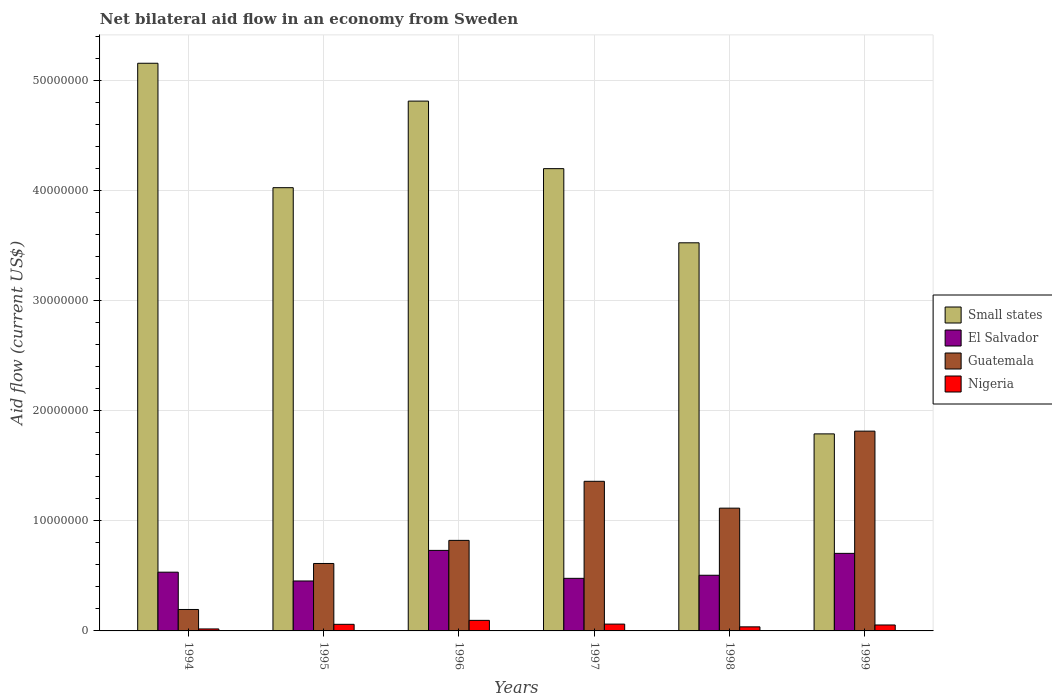Are the number of bars per tick equal to the number of legend labels?
Offer a very short reply. Yes. How many bars are there on the 3rd tick from the right?
Keep it short and to the point. 4. In how many cases, is the number of bars for a given year not equal to the number of legend labels?
Your answer should be very brief. 0. What is the net bilateral aid flow in El Salvador in 1998?
Your answer should be compact. 5.06e+06. Across all years, what is the maximum net bilateral aid flow in Nigeria?
Provide a succinct answer. 9.60e+05. Across all years, what is the minimum net bilateral aid flow in Guatemala?
Offer a very short reply. 1.95e+06. In which year was the net bilateral aid flow in Small states maximum?
Provide a short and direct response. 1994. In which year was the net bilateral aid flow in Small states minimum?
Your answer should be very brief. 1999. What is the total net bilateral aid flow in El Salvador in the graph?
Your answer should be compact. 3.41e+07. What is the difference between the net bilateral aid flow in El Salvador in 1994 and that in 1999?
Provide a succinct answer. -1.71e+06. What is the difference between the net bilateral aid flow in Nigeria in 1997 and the net bilateral aid flow in El Salvador in 1994?
Your answer should be very brief. -4.72e+06. What is the average net bilateral aid flow in El Salvador per year?
Offer a very short reply. 5.68e+06. In the year 1999, what is the difference between the net bilateral aid flow in Nigeria and net bilateral aid flow in Small states?
Your answer should be very brief. -1.74e+07. In how many years, is the net bilateral aid flow in Small states greater than 10000000 US$?
Your answer should be compact. 6. What is the ratio of the net bilateral aid flow in Guatemala in 1995 to that in 1997?
Your answer should be very brief. 0.45. Is the difference between the net bilateral aid flow in Nigeria in 1994 and 1999 greater than the difference between the net bilateral aid flow in Small states in 1994 and 1999?
Provide a succinct answer. No. What is the difference between the highest and the lowest net bilateral aid flow in Small states?
Your answer should be very brief. 3.37e+07. Is it the case that in every year, the sum of the net bilateral aid flow in Guatemala and net bilateral aid flow in El Salvador is greater than the sum of net bilateral aid flow in Nigeria and net bilateral aid flow in Small states?
Your answer should be very brief. No. What does the 3rd bar from the left in 1994 represents?
Offer a very short reply. Guatemala. What does the 4th bar from the right in 1996 represents?
Offer a terse response. Small states. How many bars are there?
Keep it short and to the point. 24. How many years are there in the graph?
Offer a terse response. 6. What is the difference between two consecutive major ticks on the Y-axis?
Your response must be concise. 1.00e+07. Are the values on the major ticks of Y-axis written in scientific E-notation?
Give a very brief answer. No. Does the graph contain any zero values?
Provide a succinct answer. No. How many legend labels are there?
Provide a succinct answer. 4. How are the legend labels stacked?
Your answer should be very brief. Vertical. What is the title of the graph?
Provide a short and direct response. Net bilateral aid flow in an economy from Sweden. What is the label or title of the X-axis?
Keep it short and to the point. Years. What is the label or title of the Y-axis?
Provide a short and direct response. Aid flow (current US$). What is the Aid flow (current US$) in Small states in 1994?
Your response must be concise. 5.16e+07. What is the Aid flow (current US$) of El Salvador in 1994?
Keep it short and to the point. 5.34e+06. What is the Aid flow (current US$) of Guatemala in 1994?
Keep it short and to the point. 1.95e+06. What is the Aid flow (current US$) of Small states in 1995?
Your response must be concise. 4.03e+07. What is the Aid flow (current US$) in El Salvador in 1995?
Ensure brevity in your answer.  4.54e+06. What is the Aid flow (current US$) in Guatemala in 1995?
Your response must be concise. 6.13e+06. What is the Aid flow (current US$) of Small states in 1996?
Your answer should be compact. 4.82e+07. What is the Aid flow (current US$) in El Salvador in 1996?
Ensure brevity in your answer.  7.32e+06. What is the Aid flow (current US$) in Guatemala in 1996?
Provide a short and direct response. 8.23e+06. What is the Aid flow (current US$) in Nigeria in 1996?
Give a very brief answer. 9.60e+05. What is the Aid flow (current US$) in Small states in 1997?
Offer a very short reply. 4.20e+07. What is the Aid flow (current US$) in El Salvador in 1997?
Ensure brevity in your answer.  4.78e+06. What is the Aid flow (current US$) in Guatemala in 1997?
Your answer should be compact. 1.36e+07. What is the Aid flow (current US$) of Nigeria in 1997?
Your answer should be compact. 6.20e+05. What is the Aid flow (current US$) in Small states in 1998?
Offer a terse response. 3.53e+07. What is the Aid flow (current US$) in El Salvador in 1998?
Provide a succinct answer. 5.06e+06. What is the Aid flow (current US$) in Guatemala in 1998?
Give a very brief answer. 1.12e+07. What is the Aid flow (current US$) of Small states in 1999?
Give a very brief answer. 1.79e+07. What is the Aid flow (current US$) of El Salvador in 1999?
Provide a short and direct response. 7.05e+06. What is the Aid flow (current US$) in Guatemala in 1999?
Ensure brevity in your answer.  1.82e+07. What is the Aid flow (current US$) of Nigeria in 1999?
Provide a short and direct response. 5.40e+05. Across all years, what is the maximum Aid flow (current US$) in Small states?
Keep it short and to the point. 5.16e+07. Across all years, what is the maximum Aid flow (current US$) of El Salvador?
Your answer should be compact. 7.32e+06. Across all years, what is the maximum Aid flow (current US$) in Guatemala?
Your answer should be very brief. 1.82e+07. Across all years, what is the maximum Aid flow (current US$) in Nigeria?
Your response must be concise. 9.60e+05. Across all years, what is the minimum Aid flow (current US$) in Small states?
Provide a succinct answer. 1.79e+07. Across all years, what is the minimum Aid flow (current US$) of El Salvador?
Your response must be concise. 4.54e+06. Across all years, what is the minimum Aid flow (current US$) in Guatemala?
Your answer should be very brief. 1.95e+06. Across all years, what is the minimum Aid flow (current US$) in Nigeria?
Provide a succinct answer. 1.80e+05. What is the total Aid flow (current US$) of Small states in the graph?
Provide a short and direct response. 2.35e+08. What is the total Aid flow (current US$) of El Salvador in the graph?
Your response must be concise. 3.41e+07. What is the total Aid flow (current US$) of Guatemala in the graph?
Make the answer very short. 5.92e+07. What is the total Aid flow (current US$) of Nigeria in the graph?
Your answer should be compact. 3.27e+06. What is the difference between the Aid flow (current US$) in Small states in 1994 and that in 1995?
Offer a very short reply. 1.13e+07. What is the difference between the Aid flow (current US$) of El Salvador in 1994 and that in 1995?
Offer a terse response. 8.00e+05. What is the difference between the Aid flow (current US$) of Guatemala in 1994 and that in 1995?
Your answer should be very brief. -4.18e+06. What is the difference between the Aid flow (current US$) of Nigeria in 1994 and that in 1995?
Offer a terse response. -4.20e+05. What is the difference between the Aid flow (current US$) of Small states in 1994 and that in 1996?
Make the answer very short. 3.44e+06. What is the difference between the Aid flow (current US$) of El Salvador in 1994 and that in 1996?
Your response must be concise. -1.98e+06. What is the difference between the Aid flow (current US$) of Guatemala in 1994 and that in 1996?
Keep it short and to the point. -6.28e+06. What is the difference between the Aid flow (current US$) in Nigeria in 1994 and that in 1996?
Give a very brief answer. -7.80e+05. What is the difference between the Aid flow (current US$) in Small states in 1994 and that in 1997?
Provide a succinct answer. 9.58e+06. What is the difference between the Aid flow (current US$) in El Salvador in 1994 and that in 1997?
Your answer should be compact. 5.60e+05. What is the difference between the Aid flow (current US$) in Guatemala in 1994 and that in 1997?
Offer a very short reply. -1.16e+07. What is the difference between the Aid flow (current US$) of Nigeria in 1994 and that in 1997?
Provide a succinct answer. -4.40e+05. What is the difference between the Aid flow (current US$) in Small states in 1994 and that in 1998?
Offer a terse response. 1.63e+07. What is the difference between the Aid flow (current US$) in El Salvador in 1994 and that in 1998?
Ensure brevity in your answer.  2.80e+05. What is the difference between the Aid flow (current US$) in Guatemala in 1994 and that in 1998?
Make the answer very short. -9.21e+06. What is the difference between the Aid flow (current US$) in Nigeria in 1994 and that in 1998?
Offer a terse response. -1.90e+05. What is the difference between the Aid flow (current US$) in Small states in 1994 and that in 1999?
Provide a short and direct response. 3.37e+07. What is the difference between the Aid flow (current US$) of El Salvador in 1994 and that in 1999?
Your answer should be very brief. -1.71e+06. What is the difference between the Aid flow (current US$) of Guatemala in 1994 and that in 1999?
Offer a very short reply. -1.62e+07. What is the difference between the Aid flow (current US$) in Nigeria in 1994 and that in 1999?
Your answer should be compact. -3.60e+05. What is the difference between the Aid flow (current US$) in Small states in 1995 and that in 1996?
Provide a short and direct response. -7.87e+06. What is the difference between the Aid flow (current US$) in El Salvador in 1995 and that in 1996?
Provide a short and direct response. -2.78e+06. What is the difference between the Aid flow (current US$) of Guatemala in 1995 and that in 1996?
Your answer should be compact. -2.10e+06. What is the difference between the Aid flow (current US$) of Nigeria in 1995 and that in 1996?
Keep it short and to the point. -3.60e+05. What is the difference between the Aid flow (current US$) in Small states in 1995 and that in 1997?
Provide a succinct answer. -1.73e+06. What is the difference between the Aid flow (current US$) in Guatemala in 1995 and that in 1997?
Provide a succinct answer. -7.47e+06. What is the difference between the Aid flow (current US$) of Small states in 1995 and that in 1998?
Your response must be concise. 5.01e+06. What is the difference between the Aid flow (current US$) in El Salvador in 1995 and that in 1998?
Ensure brevity in your answer.  -5.20e+05. What is the difference between the Aid flow (current US$) of Guatemala in 1995 and that in 1998?
Ensure brevity in your answer.  -5.03e+06. What is the difference between the Aid flow (current US$) of Small states in 1995 and that in 1999?
Your answer should be very brief. 2.24e+07. What is the difference between the Aid flow (current US$) in El Salvador in 1995 and that in 1999?
Keep it short and to the point. -2.51e+06. What is the difference between the Aid flow (current US$) in Guatemala in 1995 and that in 1999?
Your answer should be compact. -1.20e+07. What is the difference between the Aid flow (current US$) in Small states in 1996 and that in 1997?
Offer a terse response. 6.14e+06. What is the difference between the Aid flow (current US$) in El Salvador in 1996 and that in 1997?
Ensure brevity in your answer.  2.54e+06. What is the difference between the Aid flow (current US$) in Guatemala in 1996 and that in 1997?
Keep it short and to the point. -5.37e+06. What is the difference between the Aid flow (current US$) in Small states in 1996 and that in 1998?
Provide a succinct answer. 1.29e+07. What is the difference between the Aid flow (current US$) of El Salvador in 1996 and that in 1998?
Provide a short and direct response. 2.26e+06. What is the difference between the Aid flow (current US$) of Guatemala in 1996 and that in 1998?
Ensure brevity in your answer.  -2.93e+06. What is the difference between the Aid flow (current US$) of Nigeria in 1996 and that in 1998?
Ensure brevity in your answer.  5.90e+05. What is the difference between the Aid flow (current US$) in Small states in 1996 and that in 1999?
Your answer should be very brief. 3.02e+07. What is the difference between the Aid flow (current US$) of El Salvador in 1996 and that in 1999?
Your answer should be very brief. 2.70e+05. What is the difference between the Aid flow (current US$) of Guatemala in 1996 and that in 1999?
Give a very brief answer. -9.93e+06. What is the difference between the Aid flow (current US$) in Nigeria in 1996 and that in 1999?
Offer a terse response. 4.20e+05. What is the difference between the Aid flow (current US$) of Small states in 1997 and that in 1998?
Keep it short and to the point. 6.74e+06. What is the difference between the Aid flow (current US$) of El Salvador in 1997 and that in 1998?
Ensure brevity in your answer.  -2.80e+05. What is the difference between the Aid flow (current US$) in Guatemala in 1997 and that in 1998?
Your answer should be compact. 2.44e+06. What is the difference between the Aid flow (current US$) in Nigeria in 1997 and that in 1998?
Your answer should be very brief. 2.50e+05. What is the difference between the Aid flow (current US$) of Small states in 1997 and that in 1999?
Offer a terse response. 2.41e+07. What is the difference between the Aid flow (current US$) of El Salvador in 1997 and that in 1999?
Your answer should be very brief. -2.27e+06. What is the difference between the Aid flow (current US$) of Guatemala in 1997 and that in 1999?
Make the answer very short. -4.56e+06. What is the difference between the Aid flow (current US$) of Nigeria in 1997 and that in 1999?
Provide a short and direct response. 8.00e+04. What is the difference between the Aid flow (current US$) of Small states in 1998 and that in 1999?
Provide a short and direct response. 1.74e+07. What is the difference between the Aid flow (current US$) of El Salvador in 1998 and that in 1999?
Your answer should be compact. -1.99e+06. What is the difference between the Aid flow (current US$) of Guatemala in 1998 and that in 1999?
Keep it short and to the point. -7.00e+06. What is the difference between the Aid flow (current US$) in Nigeria in 1998 and that in 1999?
Your answer should be compact. -1.70e+05. What is the difference between the Aid flow (current US$) of Small states in 1994 and the Aid flow (current US$) of El Salvador in 1995?
Keep it short and to the point. 4.71e+07. What is the difference between the Aid flow (current US$) in Small states in 1994 and the Aid flow (current US$) in Guatemala in 1995?
Make the answer very short. 4.55e+07. What is the difference between the Aid flow (current US$) in Small states in 1994 and the Aid flow (current US$) in Nigeria in 1995?
Offer a terse response. 5.10e+07. What is the difference between the Aid flow (current US$) in El Salvador in 1994 and the Aid flow (current US$) in Guatemala in 1995?
Your answer should be compact. -7.90e+05. What is the difference between the Aid flow (current US$) of El Salvador in 1994 and the Aid flow (current US$) of Nigeria in 1995?
Make the answer very short. 4.74e+06. What is the difference between the Aid flow (current US$) in Guatemala in 1994 and the Aid flow (current US$) in Nigeria in 1995?
Provide a succinct answer. 1.35e+06. What is the difference between the Aid flow (current US$) of Small states in 1994 and the Aid flow (current US$) of El Salvador in 1996?
Your response must be concise. 4.43e+07. What is the difference between the Aid flow (current US$) in Small states in 1994 and the Aid flow (current US$) in Guatemala in 1996?
Give a very brief answer. 4.34e+07. What is the difference between the Aid flow (current US$) of Small states in 1994 and the Aid flow (current US$) of Nigeria in 1996?
Your answer should be compact. 5.06e+07. What is the difference between the Aid flow (current US$) in El Salvador in 1994 and the Aid flow (current US$) in Guatemala in 1996?
Offer a terse response. -2.89e+06. What is the difference between the Aid flow (current US$) in El Salvador in 1994 and the Aid flow (current US$) in Nigeria in 1996?
Give a very brief answer. 4.38e+06. What is the difference between the Aid flow (current US$) in Guatemala in 1994 and the Aid flow (current US$) in Nigeria in 1996?
Provide a succinct answer. 9.90e+05. What is the difference between the Aid flow (current US$) of Small states in 1994 and the Aid flow (current US$) of El Salvador in 1997?
Keep it short and to the point. 4.68e+07. What is the difference between the Aid flow (current US$) in Small states in 1994 and the Aid flow (current US$) in Guatemala in 1997?
Give a very brief answer. 3.80e+07. What is the difference between the Aid flow (current US$) in Small states in 1994 and the Aid flow (current US$) in Nigeria in 1997?
Make the answer very short. 5.10e+07. What is the difference between the Aid flow (current US$) of El Salvador in 1994 and the Aid flow (current US$) of Guatemala in 1997?
Provide a succinct answer. -8.26e+06. What is the difference between the Aid flow (current US$) in El Salvador in 1994 and the Aid flow (current US$) in Nigeria in 1997?
Your answer should be very brief. 4.72e+06. What is the difference between the Aid flow (current US$) of Guatemala in 1994 and the Aid flow (current US$) of Nigeria in 1997?
Your answer should be very brief. 1.33e+06. What is the difference between the Aid flow (current US$) of Small states in 1994 and the Aid flow (current US$) of El Salvador in 1998?
Offer a terse response. 4.65e+07. What is the difference between the Aid flow (current US$) of Small states in 1994 and the Aid flow (current US$) of Guatemala in 1998?
Provide a succinct answer. 4.04e+07. What is the difference between the Aid flow (current US$) in Small states in 1994 and the Aid flow (current US$) in Nigeria in 1998?
Make the answer very short. 5.12e+07. What is the difference between the Aid flow (current US$) in El Salvador in 1994 and the Aid flow (current US$) in Guatemala in 1998?
Keep it short and to the point. -5.82e+06. What is the difference between the Aid flow (current US$) in El Salvador in 1994 and the Aid flow (current US$) in Nigeria in 1998?
Provide a succinct answer. 4.97e+06. What is the difference between the Aid flow (current US$) in Guatemala in 1994 and the Aid flow (current US$) in Nigeria in 1998?
Offer a very short reply. 1.58e+06. What is the difference between the Aid flow (current US$) in Small states in 1994 and the Aid flow (current US$) in El Salvador in 1999?
Offer a terse response. 4.46e+07. What is the difference between the Aid flow (current US$) in Small states in 1994 and the Aid flow (current US$) in Guatemala in 1999?
Your response must be concise. 3.34e+07. What is the difference between the Aid flow (current US$) of Small states in 1994 and the Aid flow (current US$) of Nigeria in 1999?
Your answer should be very brief. 5.11e+07. What is the difference between the Aid flow (current US$) of El Salvador in 1994 and the Aid flow (current US$) of Guatemala in 1999?
Ensure brevity in your answer.  -1.28e+07. What is the difference between the Aid flow (current US$) in El Salvador in 1994 and the Aid flow (current US$) in Nigeria in 1999?
Make the answer very short. 4.80e+06. What is the difference between the Aid flow (current US$) in Guatemala in 1994 and the Aid flow (current US$) in Nigeria in 1999?
Keep it short and to the point. 1.41e+06. What is the difference between the Aid flow (current US$) of Small states in 1995 and the Aid flow (current US$) of El Salvador in 1996?
Your response must be concise. 3.30e+07. What is the difference between the Aid flow (current US$) of Small states in 1995 and the Aid flow (current US$) of Guatemala in 1996?
Offer a very short reply. 3.21e+07. What is the difference between the Aid flow (current US$) in Small states in 1995 and the Aid flow (current US$) in Nigeria in 1996?
Offer a very short reply. 3.93e+07. What is the difference between the Aid flow (current US$) of El Salvador in 1995 and the Aid flow (current US$) of Guatemala in 1996?
Your answer should be very brief. -3.69e+06. What is the difference between the Aid flow (current US$) of El Salvador in 1995 and the Aid flow (current US$) of Nigeria in 1996?
Offer a very short reply. 3.58e+06. What is the difference between the Aid flow (current US$) in Guatemala in 1995 and the Aid flow (current US$) in Nigeria in 1996?
Ensure brevity in your answer.  5.17e+06. What is the difference between the Aid flow (current US$) in Small states in 1995 and the Aid flow (current US$) in El Salvador in 1997?
Ensure brevity in your answer.  3.55e+07. What is the difference between the Aid flow (current US$) in Small states in 1995 and the Aid flow (current US$) in Guatemala in 1997?
Ensure brevity in your answer.  2.67e+07. What is the difference between the Aid flow (current US$) of Small states in 1995 and the Aid flow (current US$) of Nigeria in 1997?
Your answer should be very brief. 3.97e+07. What is the difference between the Aid flow (current US$) of El Salvador in 1995 and the Aid flow (current US$) of Guatemala in 1997?
Your answer should be very brief. -9.06e+06. What is the difference between the Aid flow (current US$) of El Salvador in 1995 and the Aid flow (current US$) of Nigeria in 1997?
Give a very brief answer. 3.92e+06. What is the difference between the Aid flow (current US$) in Guatemala in 1995 and the Aid flow (current US$) in Nigeria in 1997?
Provide a short and direct response. 5.51e+06. What is the difference between the Aid flow (current US$) in Small states in 1995 and the Aid flow (current US$) in El Salvador in 1998?
Your response must be concise. 3.52e+07. What is the difference between the Aid flow (current US$) of Small states in 1995 and the Aid flow (current US$) of Guatemala in 1998?
Give a very brief answer. 2.91e+07. What is the difference between the Aid flow (current US$) of Small states in 1995 and the Aid flow (current US$) of Nigeria in 1998?
Offer a terse response. 3.99e+07. What is the difference between the Aid flow (current US$) of El Salvador in 1995 and the Aid flow (current US$) of Guatemala in 1998?
Your answer should be very brief. -6.62e+06. What is the difference between the Aid flow (current US$) in El Salvador in 1995 and the Aid flow (current US$) in Nigeria in 1998?
Your response must be concise. 4.17e+06. What is the difference between the Aid flow (current US$) of Guatemala in 1995 and the Aid flow (current US$) of Nigeria in 1998?
Make the answer very short. 5.76e+06. What is the difference between the Aid flow (current US$) of Small states in 1995 and the Aid flow (current US$) of El Salvador in 1999?
Provide a short and direct response. 3.32e+07. What is the difference between the Aid flow (current US$) in Small states in 1995 and the Aid flow (current US$) in Guatemala in 1999?
Your answer should be very brief. 2.21e+07. What is the difference between the Aid flow (current US$) in Small states in 1995 and the Aid flow (current US$) in Nigeria in 1999?
Your response must be concise. 3.98e+07. What is the difference between the Aid flow (current US$) of El Salvador in 1995 and the Aid flow (current US$) of Guatemala in 1999?
Ensure brevity in your answer.  -1.36e+07. What is the difference between the Aid flow (current US$) of El Salvador in 1995 and the Aid flow (current US$) of Nigeria in 1999?
Offer a very short reply. 4.00e+06. What is the difference between the Aid flow (current US$) of Guatemala in 1995 and the Aid flow (current US$) of Nigeria in 1999?
Offer a very short reply. 5.59e+06. What is the difference between the Aid flow (current US$) of Small states in 1996 and the Aid flow (current US$) of El Salvador in 1997?
Provide a succinct answer. 4.34e+07. What is the difference between the Aid flow (current US$) of Small states in 1996 and the Aid flow (current US$) of Guatemala in 1997?
Give a very brief answer. 3.46e+07. What is the difference between the Aid flow (current US$) in Small states in 1996 and the Aid flow (current US$) in Nigeria in 1997?
Provide a succinct answer. 4.75e+07. What is the difference between the Aid flow (current US$) of El Salvador in 1996 and the Aid flow (current US$) of Guatemala in 1997?
Your answer should be very brief. -6.28e+06. What is the difference between the Aid flow (current US$) of El Salvador in 1996 and the Aid flow (current US$) of Nigeria in 1997?
Provide a short and direct response. 6.70e+06. What is the difference between the Aid flow (current US$) of Guatemala in 1996 and the Aid flow (current US$) of Nigeria in 1997?
Offer a very short reply. 7.61e+06. What is the difference between the Aid flow (current US$) in Small states in 1996 and the Aid flow (current US$) in El Salvador in 1998?
Make the answer very short. 4.31e+07. What is the difference between the Aid flow (current US$) in Small states in 1996 and the Aid flow (current US$) in Guatemala in 1998?
Ensure brevity in your answer.  3.70e+07. What is the difference between the Aid flow (current US$) of Small states in 1996 and the Aid flow (current US$) of Nigeria in 1998?
Give a very brief answer. 4.78e+07. What is the difference between the Aid flow (current US$) of El Salvador in 1996 and the Aid flow (current US$) of Guatemala in 1998?
Your answer should be very brief. -3.84e+06. What is the difference between the Aid flow (current US$) in El Salvador in 1996 and the Aid flow (current US$) in Nigeria in 1998?
Provide a succinct answer. 6.95e+06. What is the difference between the Aid flow (current US$) in Guatemala in 1996 and the Aid flow (current US$) in Nigeria in 1998?
Keep it short and to the point. 7.86e+06. What is the difference between the Aid flow (current US$) of Small states in 1996 and the Aid flow (current US$) of El Salvador in 1999?
Offer a very short reply. 4.11e+07. What is the difference between the Aid flow (current US$) in Small states in 1996 and the Aid flow (current US$) in Guatemala in 1999?
Your answer should be very brief. 3.00e+07. What is the difference between the Aid flow (current US$) of Small states in 1996 and the Aid flow (current US$) of Nigeria in 1999?
Ensure brevity in your answer.  4.76e+07. What is the difference between the Aid flow (current US$) of El Salvador in 1996 and the Aid flow (current US$) of Guatemala in 1999?
Make the answer very short. -1.08e+07. What is the difference between the Aid flow (current US$) of El Salvador in 1996 and the Aid flow (current US$) of Nigeria in 1999?
Your answer should be very brief. 6.78e+06. What is the difference between the Aid flow (current US$) of Guatemala in 1996 and the Aid flow (current US$) of Nigeria in 1999?
Ensure brevity in your answer.  7.69e+06. What is the difference between the Aid flow (current US$) of Small states in 1997 and the Aid flow (current US$) of El Salvador in 1998?
Your response must be concise. 3.70e+07. What is the difference between the Aid flow (current US$) of Small states in 1997 and the Aid flow (current US$) of Guatemala in 1998?
Give a very brief answer. 3.09e+07. What is the difference between the Aid flow (current US$) in Small states in 1997 and the Aid flow (current US$) in Nigeria in 1998?
Offer a very short reply. 4.16e+07. What is the difference between the Aid flow (current US$) of El Salvador in 1997 and the Aid flow (current US$) of Guatemala in 1998?
Provide a short and direct response. -6.38e+06. What is the difference between the Aid flow (current US$) in El Salvador in 1997 and the Aid flow (current US$) in Nigeria in 1998?
Offer a terse response. 4.41e+06. What is the difference between the Aid flow (current US$) of Guatemala in 1997 and the Aid flow (current US$) of Nigeria in 1998?
Provide a short and direct response. 1.32e+07. What is the difference between the Aid flow (current US$) in Small states in 1997 and the Aid flow (current US$) in El Salvador in 1999?
Give a very brief answer. 3.50e+07. What is the difference between the Aid flow (current US$) of Small states in 1997 and the Aid flow (current US$) of Guatemala in 1999?
Your answer should be very brief. 2.39e+07. What is the difference between the Aid flow (current US$) of Small states in 1997 and the Aid flow (current US$) of Nigeria in 1999?
Give a very brief answer. 4.15e+07. What is the difference between the Aid flow (current US$) of El Salvador in 1997 and the Aid flow (current US$) of Guatemala in 1999?
Your answer should be compact. -1.34e+07. What is the difference between the Aid flow (current US$) of El Salvador in 1997 and the Aid flow (current US$) of Nigeria in 1999?
Provide a succinct answer. 4.24e+06. What is the difference between the Aid flow (current US$) of Guatemala in 1997 and the Aid flow (current US$) of Nigeria in 1999?
Offer a very short reply. 1.31e+07. What is the difference between the Aid flow (current US$) in Small states in 1998 and the Aid flow (current US$) in El Salvador in 1999?
Your response must be concise. 2.82e+07. What is the difference between the Aid flow (current US$) in Small states in 1998 and the Aid flow (current US$) in Guatemala in 1999?
Your response must be concise. 1.71e+07. What is the difference between the Aid flow (current US$) in Small states in 1998 and the Aid flow (current US$) in Nigeria in 1999?
Give a very brief answer. 3.47e+07. What is the difference between the Aid flow (current US$) of El Salvador in 1998 and the Aid flow (current US$) of Guatemala in 1999?
Provide a short and direct response. -1.31e+07. What is the difference between the Aid flow (current US$) in El Salvador in 1998 and the Aid flow (current US$) in Nigeria in 1999?
Ensure brevity in your answer.  4.52e+06. What is the difference between the Aid flow (current US$) in Guatemala in 1998 and the Aid flow (current US$) in Nigeria in 1999?
Your answer should be compact. 1.06e+07. What is the average Aid flow (current US$) in Small states per year?
Your answer should be compact. 3.92e+07. What is the average Aid flow (current US$) in El Salvador per year?
Provide a short and direct response. 5.68e+06. What is the average Aid flow (current US$) of Guatemala per year?
Offer a terse response. 9.87e+06. What is the average Aid flow (current US$) of Nigeria per year?
Ensure brevity in your answer.  5.45e+05. In the year 1994, what is the difference between the Aid flow (current US$) of Small states and Aid flow (current US$) of El Salvador?
Make the answer very short. 4.63e+07. In the year 1994, what is the difference between the Aid flow (current US$) of Small states and Aid flow (current US$) of Guatemala?
Provide a short and direct response. 4.96e+07. In the year 1994, what is the difference between the Aid flow (current US$) of Small states and Aid flow (current US$) of Nigeria?
Ensure brevity in your answer.  5.14e+07. In the year 1994, what is the difference between the Aid flow (current US$) of El Salvador and Aid flow (current US$) of Guatemala?
Ensure brevity in your answer.  3.39e+06. In the year 1994, what is the difference between the Aid flow (current US$) in El Salvador and Aid flow (current US$) in Nigeria?
Offer a terse response. 5.16e+06. In the year 1994, what is the difference between the Aid flow (current US$) of Guatemala and Aid flow (current US$) of Nigeria?
Your answer should be very brief. 1.77e+06. In the year 1995, what is the difference between the Aid flow (current US$) in Small states and Aid flow (current US$) in El Salvador?
Offer a terse response. 3.58e+07. In the year 1995, what is the difference between the Aid flow (current US$) of Small states and Aid flow (current US$) of Guatemala?
Offer a very short reply. 3.42e+07. In the year 1995, what is the difference between the Aid flow (current US$) of Small states and Aid flow (current US$) of Nigeria?
Offer a terse response. 3.97e+07. In the year 1995, what is the difference between the Aid flow (current US$) in El Salvador and Aid flow (current US$) in Guatemala?
Make the answer very short. -1.59e+06. In the year 1995, what is the difference between the Aid flow (current US$) of El Salvador and Aid flow (current US$) of Nigeria?
Your answer should be very brief. 3.94e+06. In the year 1995, what is the difference between the Aid flow (current US$) of Guatemala and Aid flow (current US$) of Nigeria?
Offer a very short reply. 5.53e+06. In the year 1996, what is the difference between the Aid flow (current US$) of Small states and Aid flow (current US$) of El Salvador?
Offer a terse response. 4.08e+07. In the year 1996, what is the difference between the Aid flow (current US$) in Small states and Aid flow (current US$) in Guatemala?
Your answer should be very brief. 3.99e+07. In the year 1996, what is the difference between the Aid flow (current US$) in Small states and Aid flow (current US$) in Nigeria?
Your response must be concise. 4.72e+07. In the year 1996, what is the difference between the Aid flow (current US$) of El Salvador and Aid flow (current US$) of Guatemala?
Keep it short and to the point. -9.10e+05. In the year 1996, what is the difference between the Aid flow (current US$) in El Salvador and Aid flow (current US$) in Nigeria?
Offer a terse response. 6.36e+06. In the year 1996, what is the difference between the Aid flow (current US$) of Guatemala and Aid flow (current US$) of Nigeria?
Offer a very short reply. 7.27e+06. In the year 1997, what is the difference between the Aid flow (current US$) in Small states and Aid flow (current US$) in El Salvador?
Provide a succinct answer. 3.72e+07. In the year 1997, what is the difference between the Aid flow (current US$) of Small states and Aid flow (current US$) of Guatemala?
Provide a succinct answer. 2.84e+07. In the year 1997, what is the difference between the Aid flow (current US$) in Small states and Aid flow (current US$) in Nigeria?
Provide a succinct answer. 4.14e+07. In the year 1997, what is the difference between the Aid flow (current US$) of El Salvador and Aid flow (current US$) of Guatemala?
Your answer should be very brief. -8.82e+06. In the year 1997, what is the difference between the Aid flow (current US$) in El Salvador and Aid flow (current US$) in Nigeria?
Offer a terse response. 4.16e+06. In the year 1997, what is the difference between the Aid flow (current US$) of Guatemala and Aid flow (current US$) of Nigeria?
Keep it short and to the point. 1.30e+07. In the year 1998, what is the difference between the Aid flow (current US$) of Small states and Aid flow (current US$) of El Salvador?
Your answer should be compact. 3.02e+07. In the year 1998, what is the difference between the Aid flow (current US$) of Small states and Aid flow (current US$) of Guatemala?
Provide a short and direct response. 2.41e+07. In the year 1998, what is the difference between the Aid flow (current US$) of Small states and Aid flow (current US$) of Nigeria?
Your answer should be very brief. 3.49e+07. In the year 1998, what is the difference between the Aid flow (current US$) in El Salvador and Aid flow (current US$) in Guatemala?
Offer a terse response. -6.10e+06. In the year 1998, what is the difference between the Aid flow (current US$) in El Salvador and Aid flow (current US$) in Nigeria?
Your answer should be very brief. 4.69e+06. In the year 1998, what is the difference between the Aid flow (current US$) in Guatemala and Aid flow (current US$) in Nigeria?
Ensure brevity in your answer.  1.08e+07. In the year 1999, what is the difference between the Aid flow (current US$) in Small states and Aid flow (current US$) in El Salvador?
Your response must be concise. 1.09e+07. In the year 1999, what is the difference between the Aid flow (current US$) of Small states and Aid flow (current US$) of Guatemala?
Your answer should be compact. -2.50e+05. In the year 1999, what is the difference between the Aid flow (current US$) in Small states and Aid flow (current US$) in Nigeria?
Offer a terse response. 1.74e+07. In the year 1999, what is the difference between the Aid flow (current US$) of El Salvador and Aid flow (current US$) of Guatemala?
Your answer should be compact. -1.11e+07. In the year 1999, what is the difference between the Aid flow (current US$) of El Salvador and Aid flow (current US$) of Nigeria?
Your answer should be very brief. 6.51e+06. In the year 1999, what is the difference between the Aid flow (current US$) of Guatemala and Aid flow (current US$) of Nigeria?
Offer a terse response. 1.76e+07. What is the ratio of the Aid flow (current US$) of Small states in 1994 to that in 1995?
Make the answer very short. 1.28. What is the ratio of the Aid flow (current US$) of El Salvador in 1994 to that in 1995?
Offer a terse response. 1.18. What is the ratio of the Aid flow (current US$) in Guatemala in 1994 to that in 1995?
Your answer should be compact. 0.32. What is the ratio of the Aid flow (current US$) in Small states in 1994 to that in 1996?
Keep it short and to the point. 1.07. What is the ratio of the Aid flow (current US$) in El Salvador in 1994 to that in 1996?
Your answer should be compact. 0.73. What is the ratio of the Aid flow (current US$) in Guatemala in 1994 to that in 1996?
Your answer should be very brief. 0.24. What is the ratio of the Aid flow (current US$) in Nigeria in 1994 to that in 1996?
Ensure brevity in your answer.  0.19. What is the ratio of the Aid flow (current US$) of Small states in 1994 to that in 1997?
Make the answer very short. 1.23. What is the ratio of the Aid flow (current US$) of El Salvador in 1994 to that in 1997?
Offer a very short reply. 1.12. What is the ratio of the Aid flow (current US$) in Guatemala in 1994 to that in 1997?
Ensure brevity in your answer.  0.14. What is the ratio of the Aid flow (current US$) in Nigeria in 1994 to that in 1997?
Your response must be concise. 0.29. What is the ratio of the Aid flow (current US$) of Small states in 1994 to that in 1998?
Keep it short and to the point. 1.46. What is the ratio of the Aid flow (current US$) of El Salvador in 1994 to that in 1998?
Offer a terse response. 1.06. What is the ratio of the Aid flow (current US$) in Guatemala in 1994 to that in 1998?
Your answer should be very brief. 0.17. What is the ratio of the Aid flow (current US$) of Nigeria in 1994 to that in 1998?
Provide a succinct answer. 0.49. What is the ratio of the Aid flow (current US$) of Small states in 1994 to that in 1999?
Your answer should be compact. 2.88. What is the ratio of the Aid flow (current US$) in El Salvador in 1994 to that in 1999?
Your answer should be very brief. 0.76. What is the ratio of the Aid flow (current US$) of Guatemala in 1994 to that in 1999?
Your response must be concise. 0.11. What is the ratio of the Aid flow (current US$) in Nigeria in 1994 to that in 1999?
Make the answer very short. 0.33. What is the ratio of the Aid flow (current US$) of Small states in 1995 to that in 1996?
Your answer should be compact. 0.84. What is the ratio of the Aid flow (current US$) in El Salvador in 1995 to that in 1996?
Provide a short and direct response. 0.62. What is the ratio of the Aid flow (current US$) of Guatemala in 1995 to that in 1996?
Make the answer very short. 0.74. What is the ratio of the Aid flow (current US$) of Nigeria in 1995 to that in 1996?
Ensure brevity in your answer.  0.62. What is the ratio of the Aid flow (current US$) in Small states in 1995 to that in 1997?
Offer a very short reply. 0.96. What is the ratio of the Aid flow (current US$) in El Salvador in 1995 to that in 1997?
Make the answer very short. 0.95. What is the ratio of the Aid flow (current US$) in Guatemala in 1995 to that in 1997?
Offer a terse response. 0.45. What is the ratio of the Aid flow (current US$) in Nigeria in 1995 to that in 1997?
Make the answer very short. 0.97. What is the ratio of the Aid flow (current US$) in Small states in 1995 to that in 1998?
Your answer should be compact. 1.14. What is the ratio of the Aid flow (current US$) of El Salvador in 1995 to that in 1998?
Provide a succinct answer. 0.9. What is the ratio of the Aid flow (current US$) of Guatemala in 1995 to that in 1998?
Your answer should be very brief. 0.55. What is the ratio of the Aid flow (current US$) of Nigeria in 1995 to that in 1998?
Offer a terse response. 1.62. What is the ratio of the Aid flow (current US$) in Small states in 1995 to that in 1999?
Provide a short and direct response. 2.25. What is the ratio of the Aid flow (current US$) in El Salvador in 1995 to that in 1999?
Keep it short and to the point. 0.64. What is the ratio of the Aid flow (current US$) in Guatemala in 1995 to that in 1999?
Make the answer very short. 0.34. What is the ratio of the Aid flow (current US$) of Small states in 1996 to that in 1997?
Your response must be concise. 1.15. What is the ratio of the Aid flow (current US$) of El Salvador in 1996 to that in 1997?
Ensure brevity in your answer.  1.53. What is the ratio of the Aid flow (current US$) of Guatemala in 1996 to that in 1997?
Give a very brief answer. 0.61. What is the ratio of the Aid flow (current US$) in Nigeria in 1996 to that in 1997?
Your response must be concise. 1.55. What is the ratio of the Aid flow (current US$) of Small states in 1996 to that in 1998?
Keep it short and to the point. 1.37. What is the ratio of the Aid flow (current US$) in El Salvador in 1996 to that in 1998?
Your answer should be compact. 1.45. What is the ratio of the Aid flow (current US$) of Guatemala in 1996 to that in 1998?
Ensure brevity in your answer.  0.74. What is the ratio of the Aid flow (current US$) of Nigeria in 1996 to that in 1998?
Offer a terse response. 2.59. What is the ratio of the Aid flow (current US$) in Small states in 1996 to that in 1999?
Give a very brief answer. 2.69. What is the ratio of the Aid flow (current US$) of El Salvador in 1996 to that in 1999?
Your answer should be compact. 1.04. What is the ratio of the Aid flow (current US$) in Guatemala in 1996 to that in 1999?
Provide a succinct answer. 0.45. What is the ratio of the Aid flow (current US$) in Nigeria in 1996 to that in 1999?
Make the answer very short. 1.78. What is the ratio of the Aid flow (current US$) of Small states in 1997 to that in 1998?
Your answer should be very brief. 1.19. What is the ratio of the Aid flow (current US$) in El Salvador in 1997 to that in 1998?
Keep it short and to the point. 0.94. What is the ratio of the Aid flow (current US$) in Guatemala in 1997 to that in 1998?
Give a very brief answer. 1.22. What is the ratio of the Aid flow (current US$) of Nigeria in 1997 to that in 1998?
Offer a very short reply. 1.68. What is the ratio of the Aid flow (current US$) of Small states in 1997 to that in 1999?
Your answer should be compact. 2.35. What is the ratio of the Aid flow (current US$) in El Salvador in 1997 to that in 1999?
Your response must be concise. 0.68. What is the ratio of the Aid flow (current US$) of Guatemala in 1997 to that in 1999?
Offer a terse response. 0.75. What is the ratio of the Aid flow (current US$) in Nigeria in 1997 to that in 1999?
Offer a very short reply. 1.15. What is the ratio of the Aid flow (current US$) of Small states in 1998 to that in 1999?
Your answer should be very brief. 1.97. What is the ratio of the Aid flow (current US$) of El Salvador in 1998 to that in 1999?
Offer a very short reply. 0.72. What is the ratio of the Aid flow (current US$) of Guatemala in 1998 to that in 1999?
Your response must be concise. 0.61. What is the ratio of the Aid flow (current US$) in Nigeria in 1998 to that in 1999?
Your answer should be compact. 0.69. What is the difference between the highest and the second highest Aid flow (current US$) of Small states?
Offer a terse response. 3.44e+06. What is the difference between the highest and the second highest Aid flow (current US$) in Guatemala?
Offer a very short reply. 4.56e+06. What is the difference between the highest and the lowest Aid flow (current US$) of Small states?
Make the answer very short. 3.37e+07. What is the difference between the highest and the lowest Aid flow (current US$) in El Salvador?
Your response must be concise. 2.78e+06. What is the difference between the highest and the lowest Aid flow (current US$) in Guatemala?
Make the answer very short. 1.62e+07. What is the difference between the highest and the lowest Aid flow (current US$) in Nigeria?
Provide a short and direct response. 7.80e+05. 